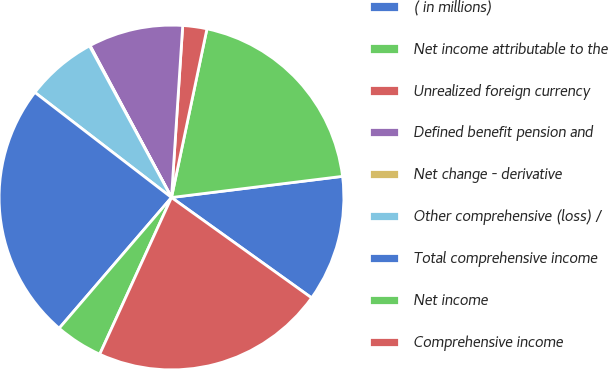<chart> <loc_0><loc_0><loc_500><loc_500><pie_chart><fcel>( in millions)<fcel>Net income attributable to the<fcel>Unrealized foreign currency<fcel>Defined benefit pension and<fcel>Net change - derivative<fcel>Other comprehensive (loss) /<fcel>Total comprehensive income<fcel>Net income<fcel>Comprehensive income<nl><fcel>11.85%<fcel>19.74%<fcel>2.26%<fcel>8.87%<fcel>0.06%<fcel>6.67%<fcel>24.14%<fcel>4.46%<fcel>21.94%<nl></chart> 